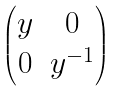<formula> <loc_0><loc_0><loc_500><loc_500>\begin{pmatrix} y & 0 \\ 0 & y ^ { - 1 } \end{pmatrix}</formula> 